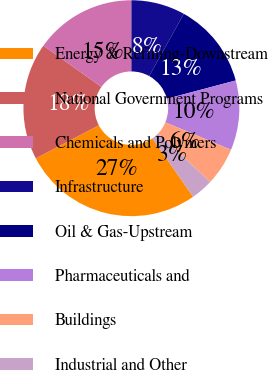Convert chart. <chart><loc_0><loc_0><loc_500><loc_500><pie_chart><fcel>Energy & Refining-Downstream<fcel>National Government Programs<fcel>Chemicals and Polymers<fcel>Infrastructure<fcel>Oil & Gas-Upstream<fcel>Pharmaceuticals and<fcel>Buildings<fcel>Industrial and Other<nl><fcel>27.01%<fcel>17.53%<fcel>15.17%<fcel>8.06%<fcel>12.8%<fcel>10.43%<fcel>5.69%<fcel>3.32%<nl></chart> 